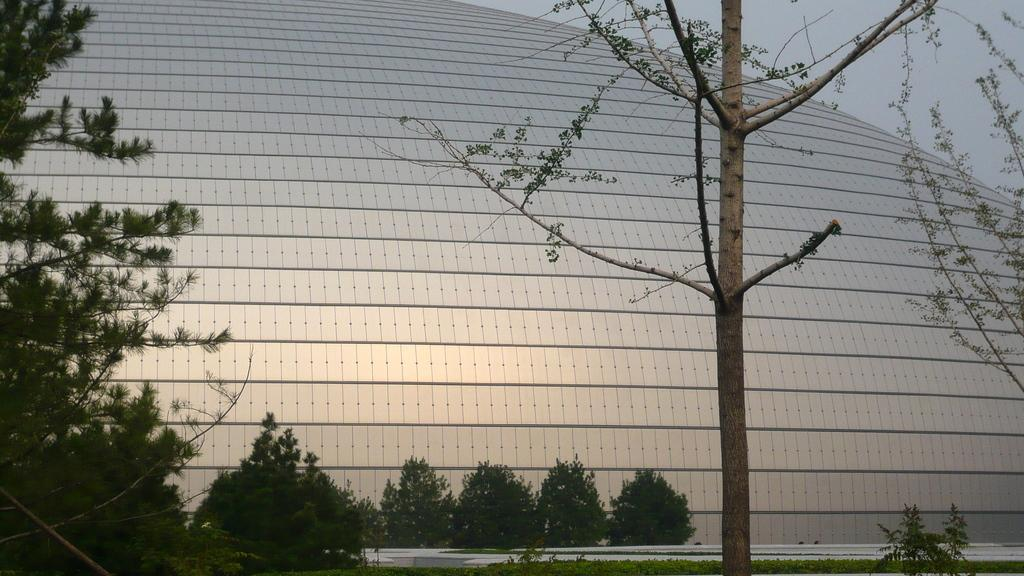What is the main subject in the center of the image? There is a building in the center of the image. What type of natural elements can be seen in the image? There are trees visible in the image. What can be seen in the background of the image? The sky is visible in the background of the image. What type of flower is growing on the roof of the building in the image? There is no flower growing on the roof of the building in the image. 